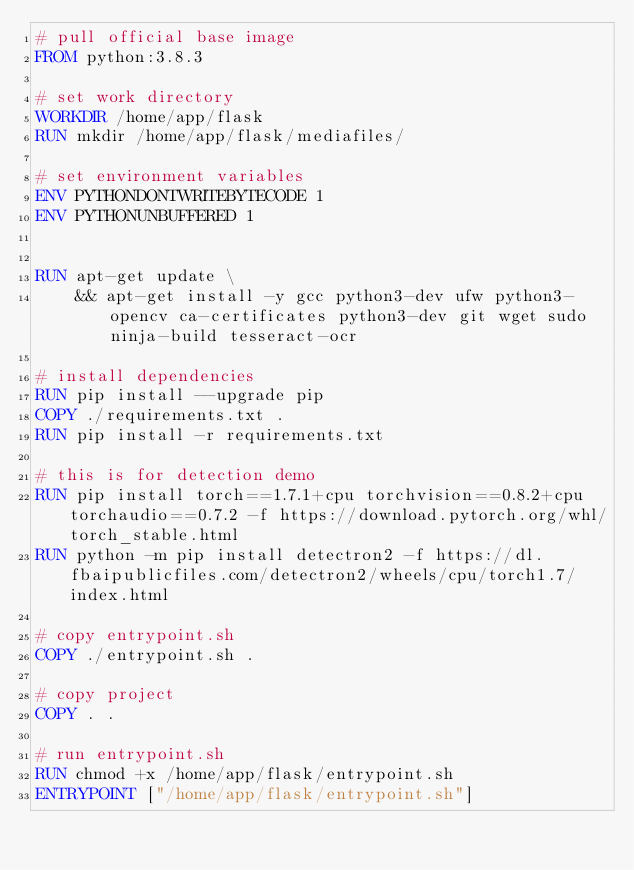<code> <loc_0><loc_0><loc_500><loc_500><_Dockerfile_># pull official base image
FROM python:3.8.3

# set work directory
WORKDIR /home/app/flask
RUN mkdir /home/app/flask/mediafiles/

# set environment variables
ENV PYTHONDONTWRITEBYTECODE 1
ENV PYTHONUNBUFFERED 1


RUN apt-get update \
    && apt-get install -y gcc python3-dev ufw python3-opencv ca-certificates python3-dev git wget sudo ninja-build tesseract-ocr

# install dependencies
RUN pip install --upgrade pip
COPY ./requirements.txt .
RUN pip install -r requirements.txt

# this is for detection demo
RUN pip install torch==1.7.1+cpu torchvision==0.8.2+cpu torchaudio==0.7.2 -f https://download.pytorch.org/whl/torch_stable.html
RUN python -m pip install detectron2 -f https://dl.fbaipublicfiles.com/detectron2/wheels/cpu/torch1.7/index.html

# copy entrypoint.sh
COPY ./entrypoint.sh .

# copy project
COPY . .

# run entrypoint.sh
RUN chmod +x /home/app/flask/entrypoint.sh
ENTRYPOINT ["/home/app/flask/entrypoint.sh"]</code> 